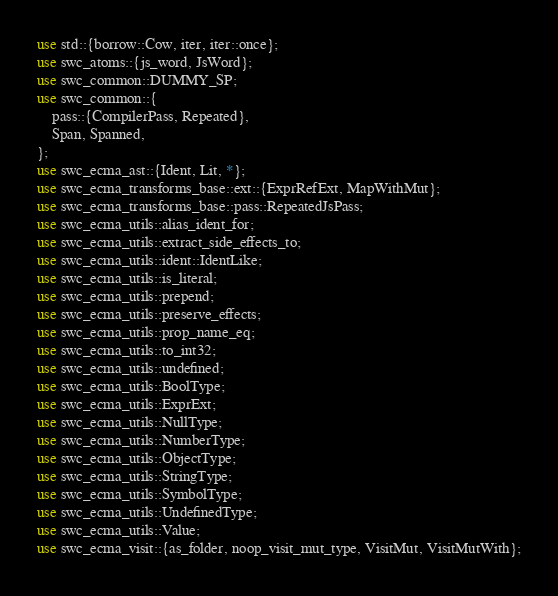<code> <loc_0><loc_0><loc_500><loc_500><_Rust_>use std::{borrow::Cow, iter, iter::once};
use swc_atoms::{js_word, JsWord};
use swc_common::DUMMY_SP;
use swc_common::{
    pass::{CompilerPass, Repeated},
    Span, Spanned,
};
use swc_ecma_ast::{Ident, Lit, *};
use swc_ecma_transforms_base::ext::{ExprRefExt, MapWithMut};
use swc_ecma_transforms_base::pass::RepeatedJsPass;
use swc_ecma_utils::alias_ident_for;
use swc_ecma_utils::extract_side_effects_to;
use swc_ecma_utils::ident::IdentLike;
use swc_ecma_utils::is_literal;
use swc_ecma_utils::prepend;
use swc_ecma_utils::preserve_effects;
use swc_ecma_utils::prop_name_eq;
use swc_ecma_utils::to_int32;
use swc_ecma_utils::undefined;
use swc_ecma_utils::BoolType;
use swc_ecma_utils::ExprExt;
use swc_ecma_utils::NullType;
use swc_ecma_utils::NumberType;
use swc_ecma_utils::ObjectType;
use swc_ecma_utils::StringType;
use swc_ecma_utils::SymbolType;
use swc_ecma_utils::UndefinedType;
use swc_ecma_utils::Value;
use swc_ecma_visit::{as_folder, noop_visit_mut_type, VisitMut, VisitMutWith};</code> 